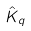<formula> <loc_0><loc_0><loc_500><loc_500>\hat { K } _ { q }</formula> 